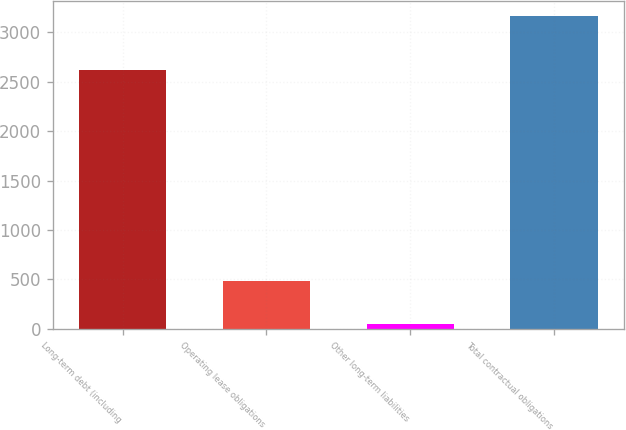Convert chart to OTSL. <chart><loc_0><loc_0><loc_500><loc_500><bar_chart><fcel>Long-term debt (including<fcel>Operating lease obligations<fcel>Other long-term liabilities<fcel>Total contractual obligations<nl><fcel>2618<fcel>488<fcel>50<fcel>3159<nl></chart> 